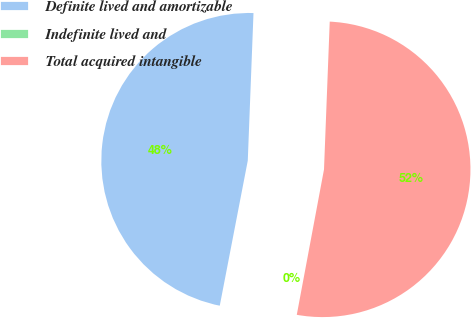Convert chart. <chart><loc_0><loc_0><loc_500><loc_500><pie_chart><fcel>Definite lived and amortizable<fcel>Indefinite lived and<fcel>Total acquired intangible<nl><fcel>47.58%<fcel>0.09%<fcel>52.33%<nl></chart> 